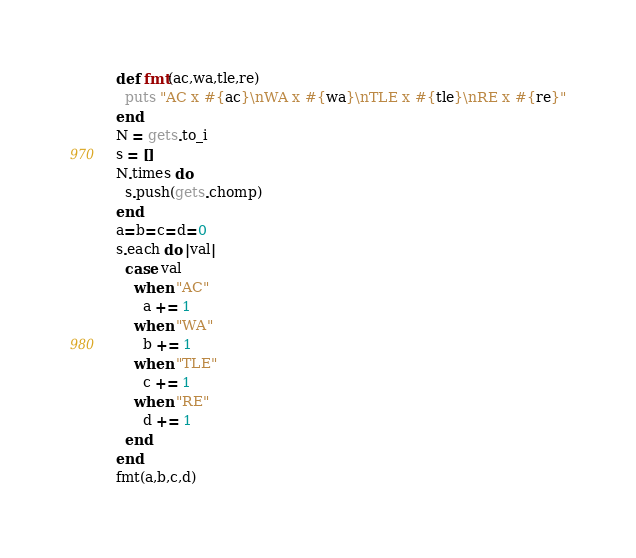Convert code to text. <code><loc_0><loc_0><loc_500><loc_500><_Ruby_>def fmt(ac,wa,tle,re)
  puts "AC x #{ac}\nWA x #{wa}\nTLE x #{tle}\nRE x #{re}"
end
N = gets.to_i
s = []
N.times do
  s.push(gets.chomp)
end
a=b=c=d=0
s.each do |val|
  case val
    when "AC"
      a += 1
    when "WA"
      b += 1
    when "TLE"
      c += 1
    when "RE"
      d += 1
  end
end
fmt(a,b,c,d)</code> 